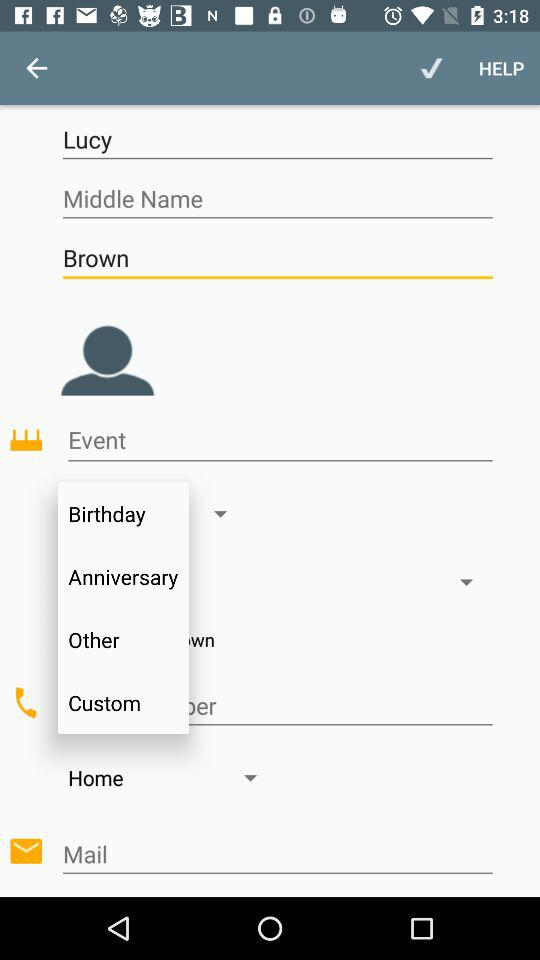What is the user's first name? The user's first name is Lucy. 